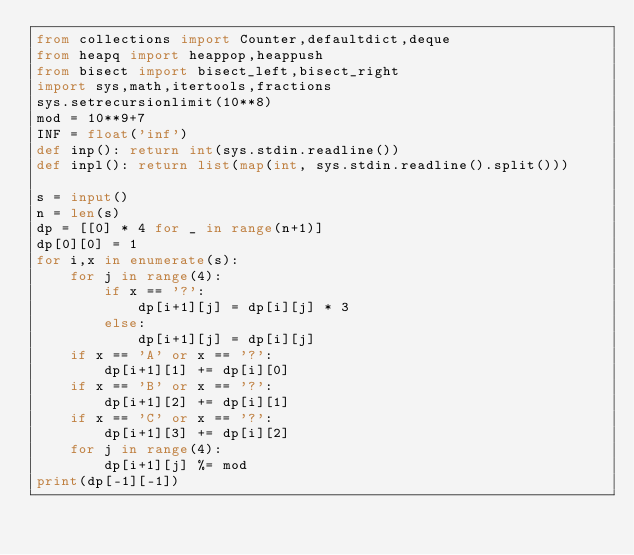<code> <loc_0><loc_0><loc_500><loc_500><_Python_>from collections import Counter,defaultdict,deque
from heapq import heappop,heappush
from bisect import bisect_left,bisect_right 
import sys,math,itertools,fractions
sys.setrecursionlimit(10**8)
mod = 10**9+7
INF = float('inf')
def inp(): return int(sys.stdin.readline())
def inpl(): return list(map(int, sys.stdin.readline().split()))

s = input()
n = len(s)
dp = [[0] * 4 for _ in range(n+1)]
dp[0][0] = 1
for i,x in enumerate(s):
    for j in range(4):
        if x == '?':
            dp[i+1][j] = dp[i][j] * 3
        else:
            dp[i+1][j] = dp[i][j]
    if x == 'A' or x == '?':
        dp[i+1][1] += dp[i][0]
    if x == 'B' or x == '?':
        dp[i+1][2] += dp[i][1]
    if x == 'C' or x == '?':
        dp[i+1][3] += dp[i][2]
    for j in range(4):
        dp[i+1][j] %= mod
print(dp[-1][-1])</code> 